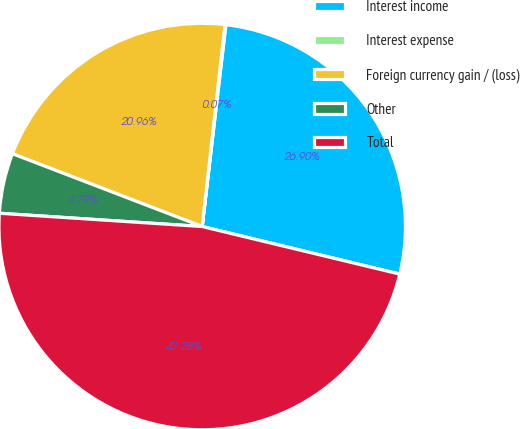Convert chart to OTSL. <chart><loc_0><loc_0><loc_500><loc_500><pie_chart><fcel>Interest income<fcel>Interest expense<fcel>Foreign currency gain / (loss)<fcel>Other<fcel>Total<nl><fcel>26.9%<fcel>0.07%<fcel>20.96%<fcel>4.79%<fcel>47.28%<nl></chart> 